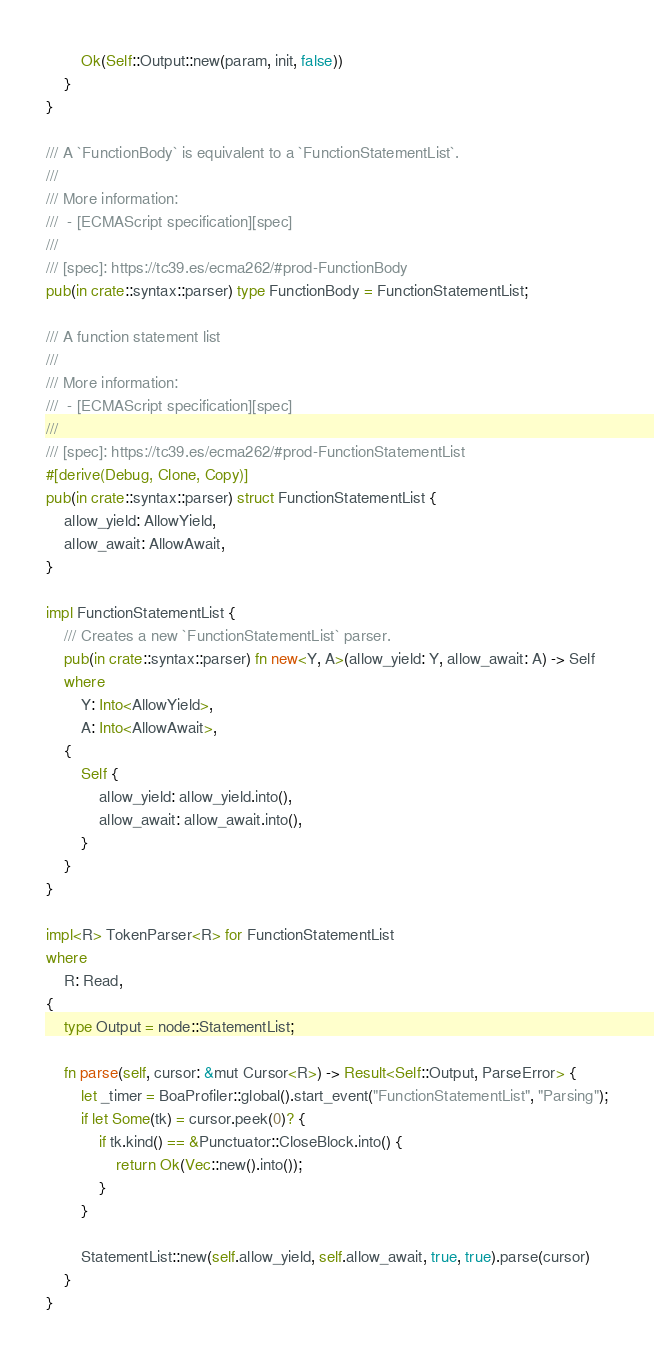Convert code to text. <code><loc_0><loc_0><loc_500><loc_500><_Rust_>        Ok(Self::Output::new(param, init, false))
    }
}

/// A `FunctionBody` is equivalent to a `FunctionStatementList`.
///
/// More information:
///  - [ECMAScript specification][spec]
///
/// [spec]: https://tc39.es/ecma262/#prod-FunctionBody
pub(in crate::syntax::parser) type FunctionBody = FunctionStatementList;

/// A function statement list
///
/// More information:
///  - [ECMAScript specification][spec]
///
/// [spec]: https://tc39.es/ecma262/#prod-FunctionStatementList
#[derive(Debug, Clone, Copy)]
pub(in crate::syntax::parser) struct FunctionStatementList {
    allow_yield: AllowYield,
    allow_await: AllowAwait,
}

impl FunctionStatementList {
    /// Creates a new `FunctionStatementList` parser.
    pub(in crate::syntax::parser) fn new<Y, A>(allow_yield: Y, allow_await: A) -> Self
    where
        Y: Into<AllowYield>,
        A: Into<AllowAwait>,
    {
        Self {
            allow_yield: allow_yield.into(),
            allow_await: allow_await.into(),
        }
    }
}

impl<R> TokenParser<R> for FunctionStatementList
where
    R: Read,
{
    type Output = node::StatementList;

    fn parse(self, cursor: &mut Cursor<R>) -> Result<Self::Output, ParseError> {
        let _timer = BoaProfiler::global().start_event("FunctionStatementList", "Parsing");
        if let Some(tk) = cursor.peek(0)? {
            if tk.kind() == &Punctuator::CloseBlock.into() {
                return Ok(Vec::new().into());
            }
        }

        StatementList::new(self.allow_yield, self.allow_await, true, true).parse(cursor)
    }
}
</code> 